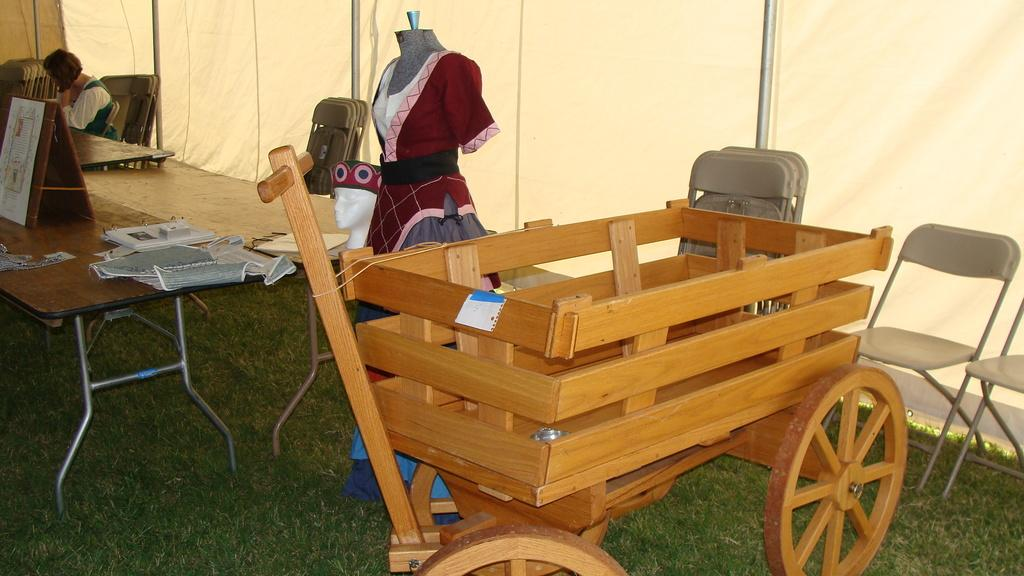What type of furniture is present in the image? There is a cart, chairs, and a table in the image. What items can be seen on the furniture? There are dresses in the image. Who is present in the image? There is a woman in the image. What can be seen in the background of the image? There is a curtain and a wall in the background of the image. How does the woman in the image sort the sand? There is no sand present in the image, so the woman cannot sort any sand. 